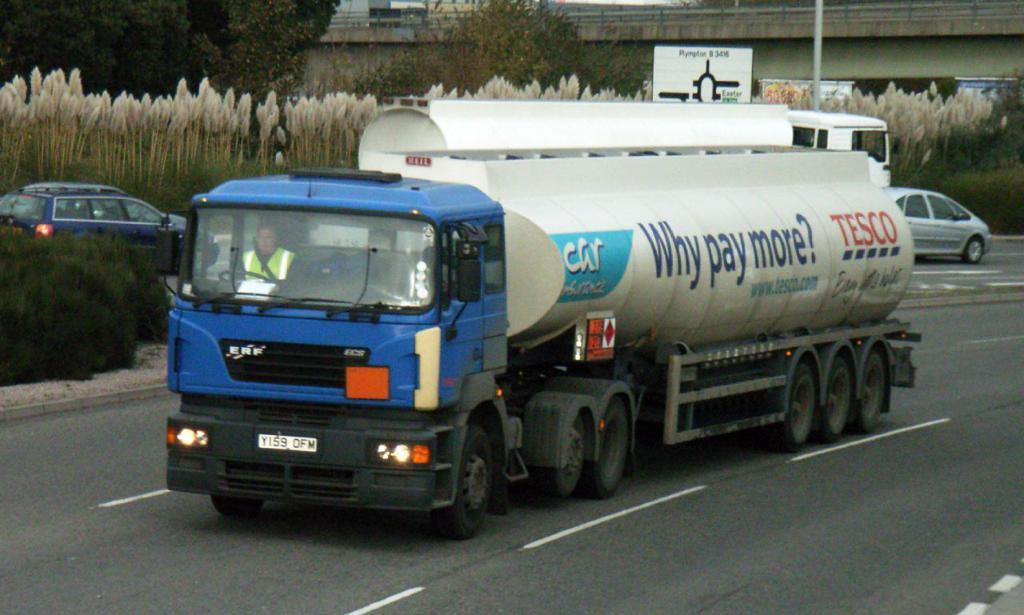Please provide a concise description of this image. In this image, in the middle, we can see a vehicle which is moving on the road, in the vehicle, we can see a person sitting. On the right side, we can see a car moving on the road. On the right side, we can also see another vehicle. On the left side, we can see a vehicle moving on the road. On the left side, we can see some plants. In the background, we can see some plants, trees, bridge, hoarding and a pole. At the bottom, we can see a road. 